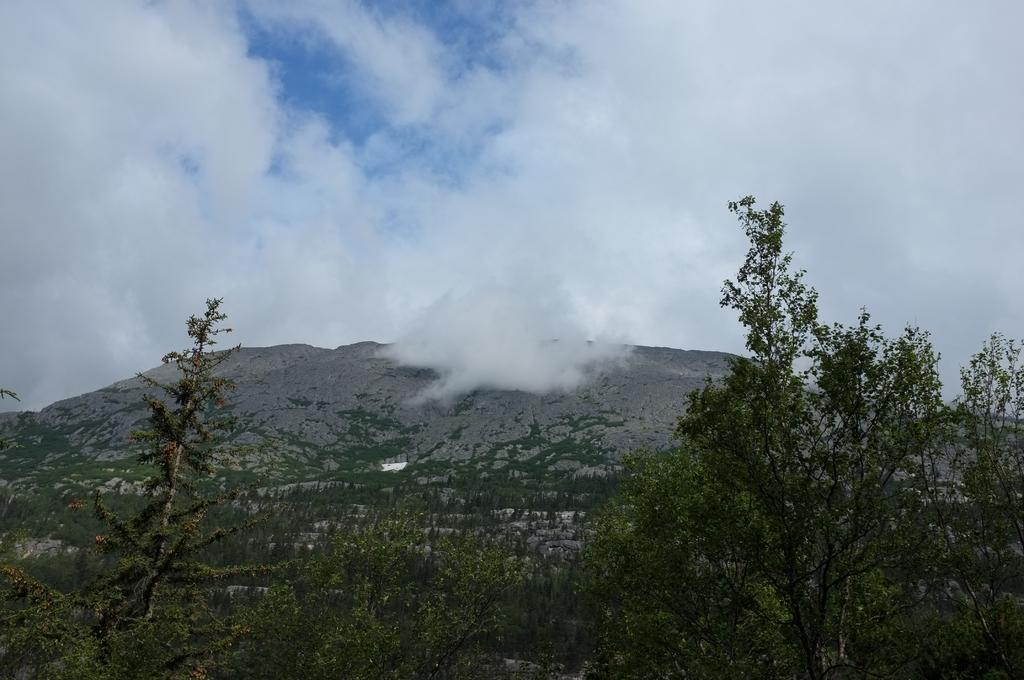What type of vegetation can be seen in the image? There is a group of trees in the image. What type of landscape feature is visible in the image? There are hills visible in the image. What part of the natural environment is visible in the image? The sky is visible in the image. How would you describe the sky in the image? The sky appears to be cloudy. What type of cord is used to connect the trees in the image? There is no cord connecting the trees in the image; they are separate trees. Can you hear a whistle in the image? There is no whistle present in the image. 